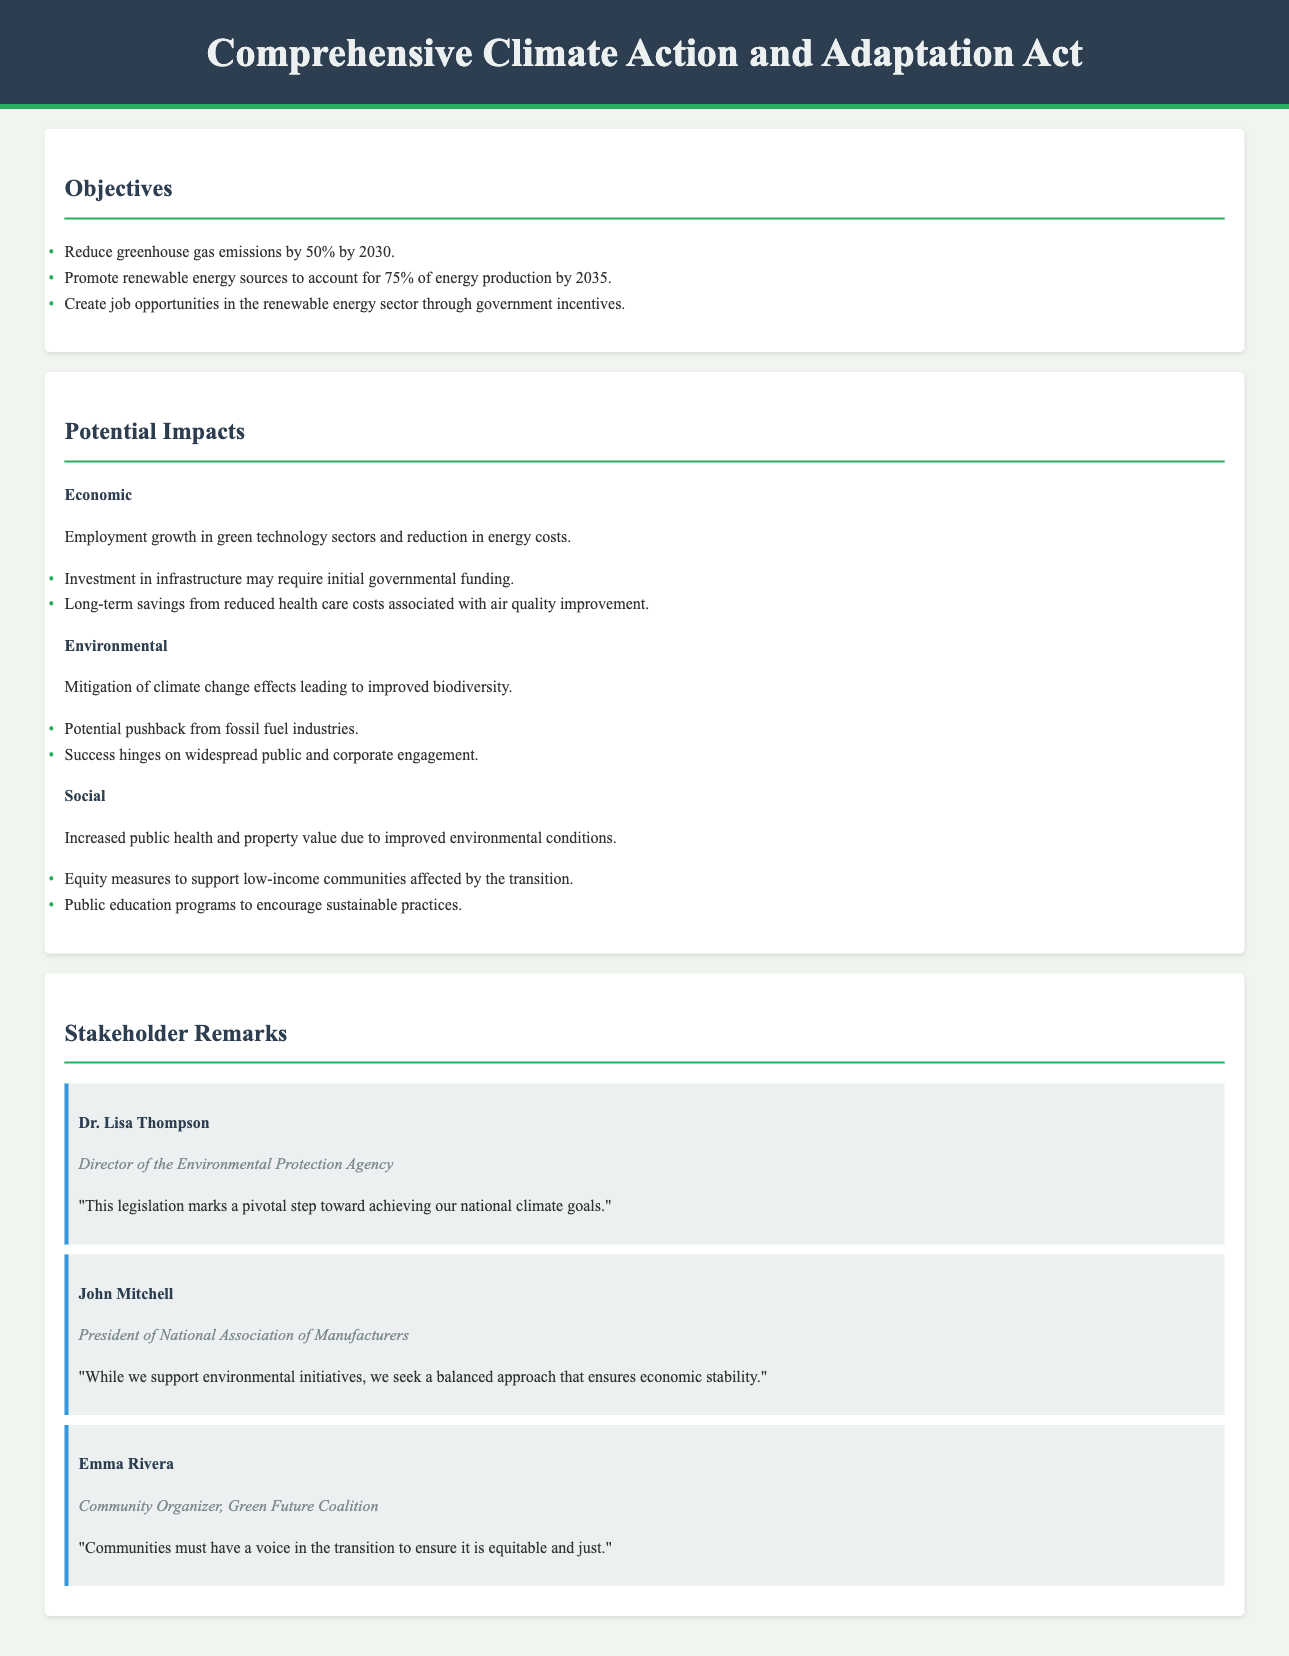What is the title of the document? The title of the document is prominently displayed in the header section.
Answer: Comprehensive Climate Action and Adaptation Act What is the emission reduction target by 2030? The document specifies the goal of reducing greenhouse gas emissions to a certain level by a specific year.
Answer: 50% What percentage of energy production is aimed to be from renewable sources by 2035? The document outlines a target for renewable energy's contribution to energy production.
Answer: 75% Who is the Director of the Environmental Protection Agency? The document lists remarks from various stakeholders alongside their titles, including the director’s name.
Answer: Dr. Lisa Thompson What is one potential economic impact mentioned in the document? The document provides insights into economic consequences, particularly related to job growth and costs.
Answer: Employment growth in green technology sectors What does the document state about public health? The document includes potential social impacts, highlighting an effect on health outcomes.
Answer: Increased public health What is Emma Rivera's position? The document identifies the roles of different stakeholders who provide remarks on the proposal.
Answer: Community Organizer, Green Future Coalition What is one objective of the Comprehensive Climate Action and Adaptation Act? The document outlines several key objectives aimed at addressing climate change.
Answer: Create job opportunities in the renewable energy sector What does John Mitchell advocate for regarding environmental initiatives? The document summarizes remarks from stakeholders, revealing differing perspectives on balance and stability.
Answer: A balanced approach that ensures economic stability 